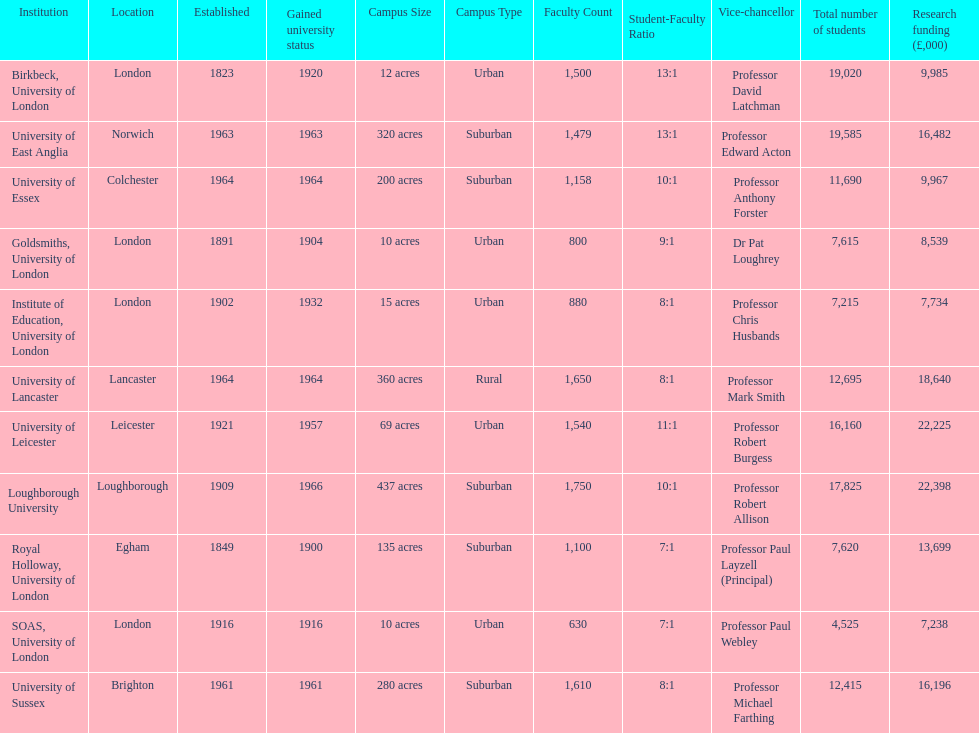What is the most recent institution to gain university status? Loughborough University. 